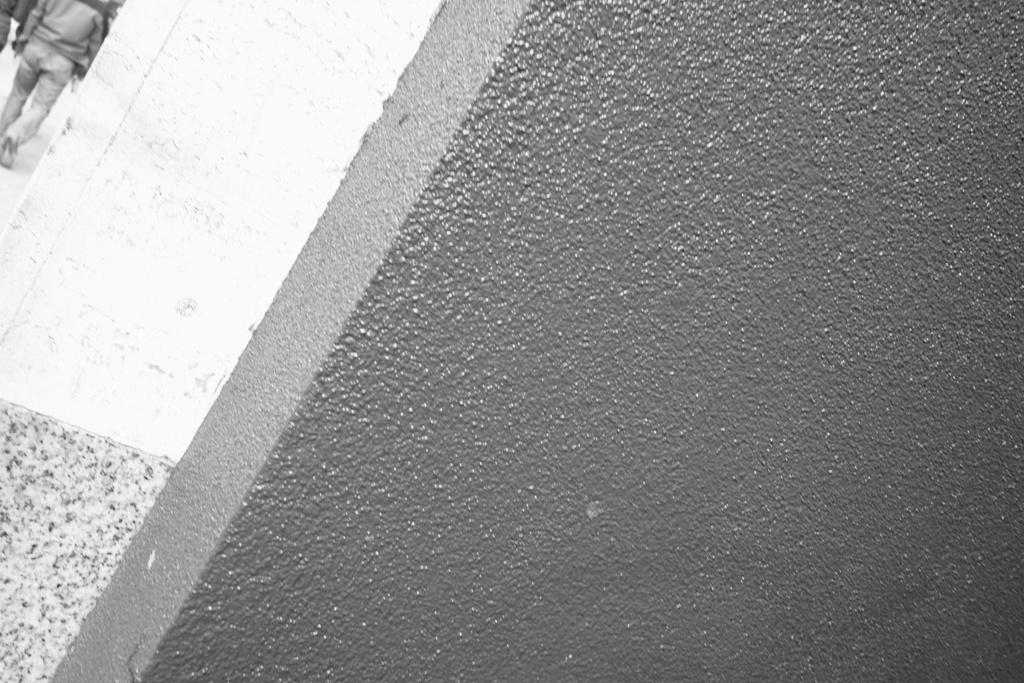What type of structure can be seen in the image? There is a wall in the image. Are there any other architectural features present? Yes, there is a pillar in the image. What is happening near the pillar? A man is walking on a path near the pillar. What type of truck can be seen driving through the wall in the image? There is no truck present in the image, and the wall is not being driven through. 